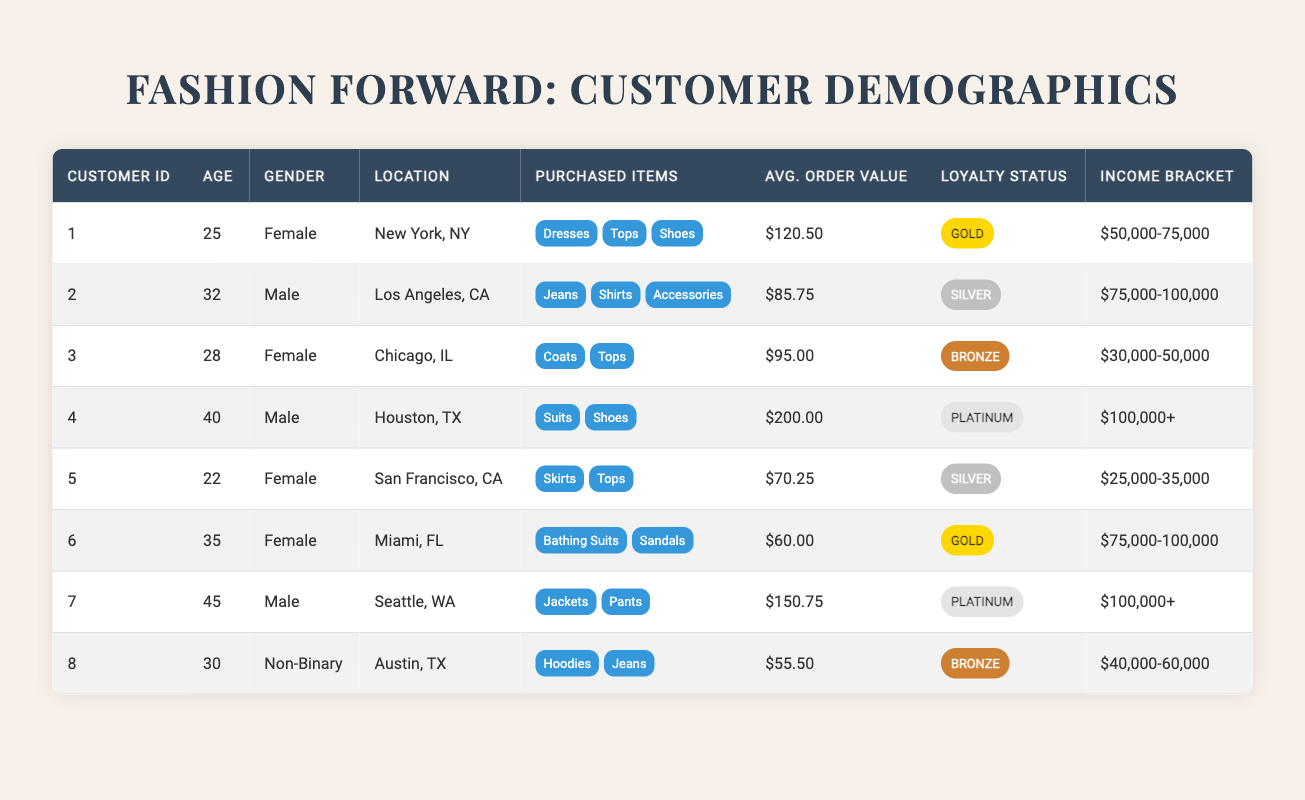What is the average order value of the female customers? The average order value for female customers can be calculated by summing their average order values: ($120.50 + $95.00 + $70.25 + $60.00) = $345.75. There are four female customers, so we divide: $345.75 / 4 = $86.4375, which can be rounded to $86.44.
Answer: $86.44 Which customer has the highest average order value? By looking at the average order values listed in the table, the customer with ID 4 has the highest average order value at $200.00.
Answer: Customer ID 4 Is there a customer from Miami who belongs to the Gold loyalty status? Yes, customer ID 6 from Miami has a Gold loyalty status as indicated in the table.
Answer: Yes How many customers have a loyalty status of Platinum? From the table, there are two customers (IDs 4 and 7) who have a Platinum loyalty status.
Answer: 2 What is the total average order value of customers from the income bracket "100,000+"? Customers in this income bracket are IDs 4 and 7. Their average order values are $200.00 and $150.75, respectively. Adding these gives $200.00 + $150.75 = $350.75.
Answer: $350.75 How many customers located in California have an average order value above $80? Customers from California are IDs 2 (Los Angeles) with $85.75 and ID 5 (San Francisco) with $70.25. Only customer ID 2 has an average order value above $80.
Answer: 1 What percentage of the customers are Male? There are three male customers (IDs 2, 4, and 7) out of a total of eight customers. The percentage is (3/8) * 100 = 37.5%.
Answer: 37.5% Are there any customers who have purchased "Suits"? Yes, customer ID 4 has purchased "Suits" as shown in the purchased items column.
Answer: Yes Which customer has the lowest average order value and what is it? Customer ID 6 has the lowest average order value listed at $55.50.
Answer: Customer ID 8, $55.50 What is the average age of customers with Silver loyalty status? The customers with Silver loyalty status are IDs 2, 5, and 6. Their ages are 32, 22, and 35 respectively. The average age is (32 + 22 + 35) / 3 = 29.67, which is approximately 30 when rounded.
Answer: 30 